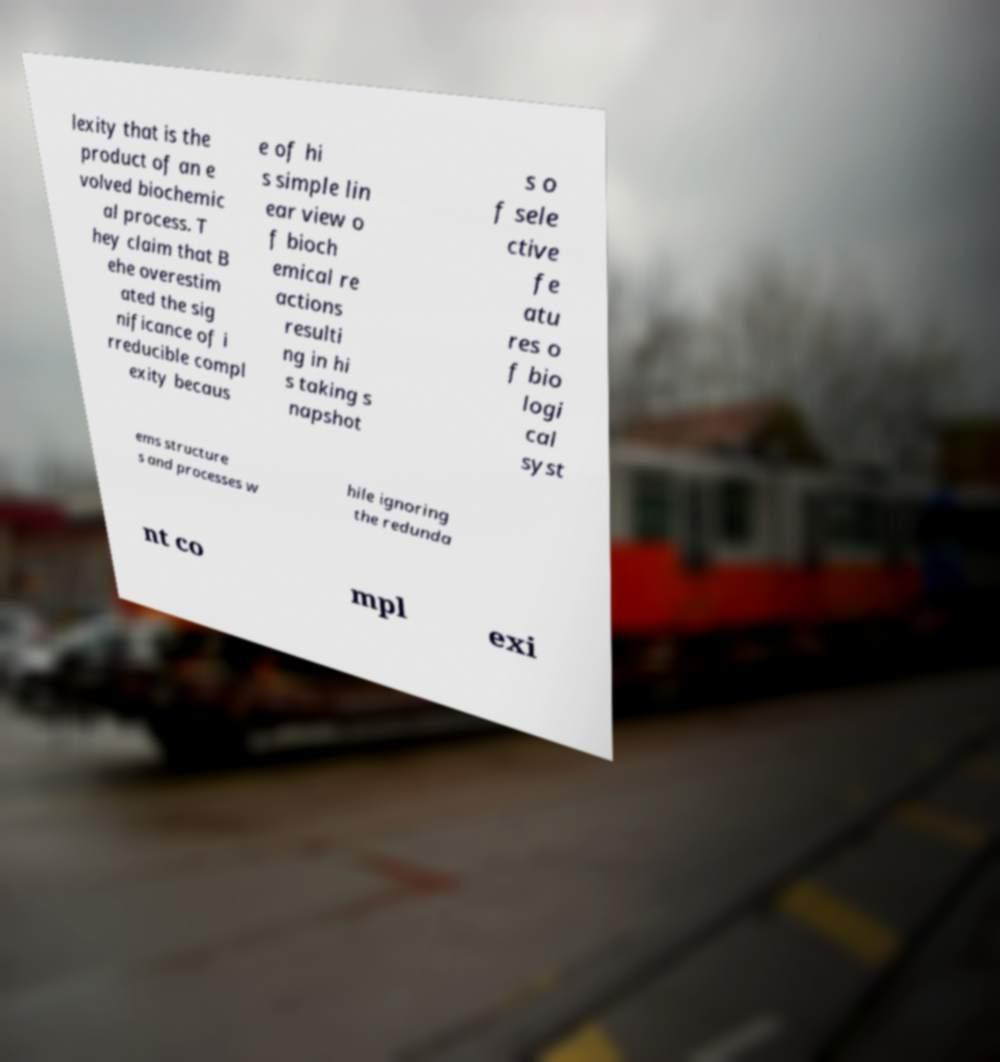There's text embedded in this image that I need extracted. Can you transcribe it verbatim? lexity that is the product of an e volved biochemic al process. T hey claim that B ehe overestim ated the sig nificance of i rreducible compl exity becaus e of hi s simple lin ear view o f bioch emical re actions resulti ng in hi s taking s napshot s o f sele ctive fe atu res o f bio logi cal syst ems structure s and processes w hile ignoring the redunda nt co mpl exi 